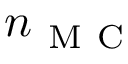Convert formula to latex. <formula><loc_0><loc_0><loc_500><loc_500>n _ { M C }</formula> 